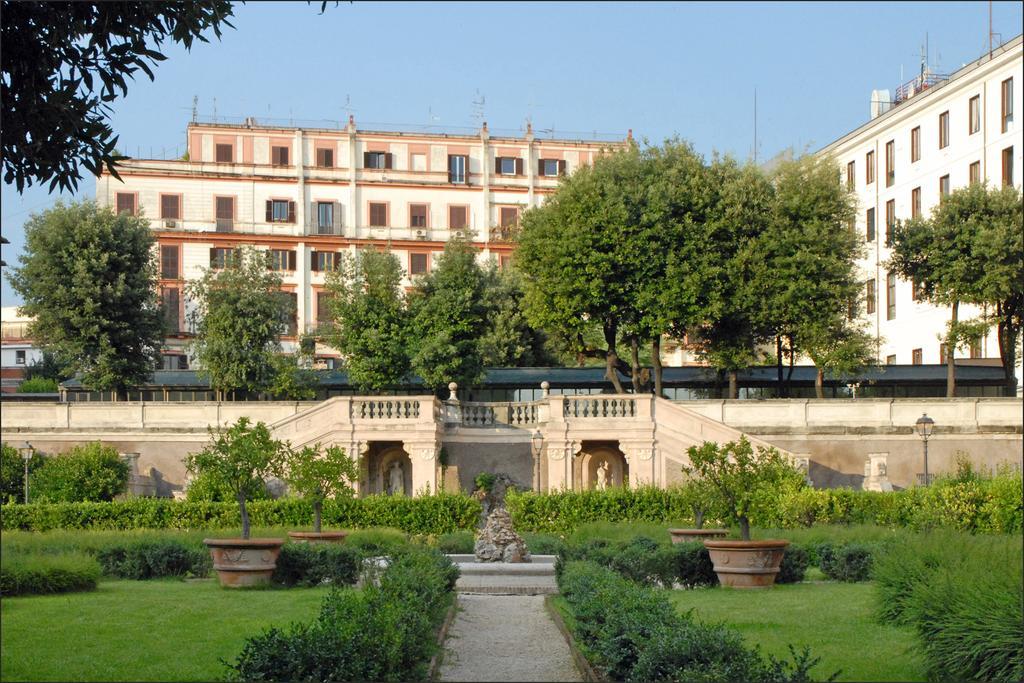Can you describe this image briefly? There are grass lawns, bushes and pot with plants in the front. In the back there's a wall. Near to that there are railings. Also there are trees. In the background there are buildings with windows. Also there is sky. 